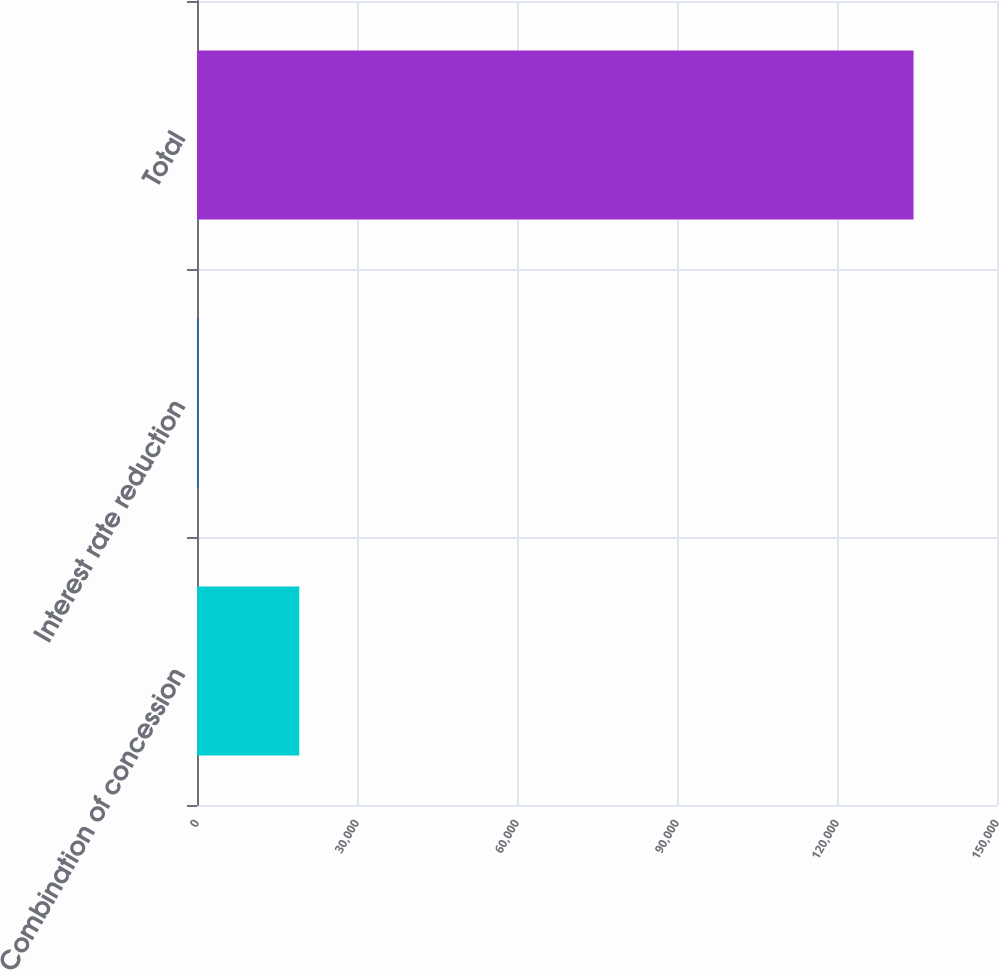<chart> <loc_0><loc_0><loc_500><loc_500><bar_chart><fcel>Combination of concession<fcel>Interest rate reduction<fcel>Total<nl><fcel>19167<fcel>255<fcel>134351<nl></chart> 